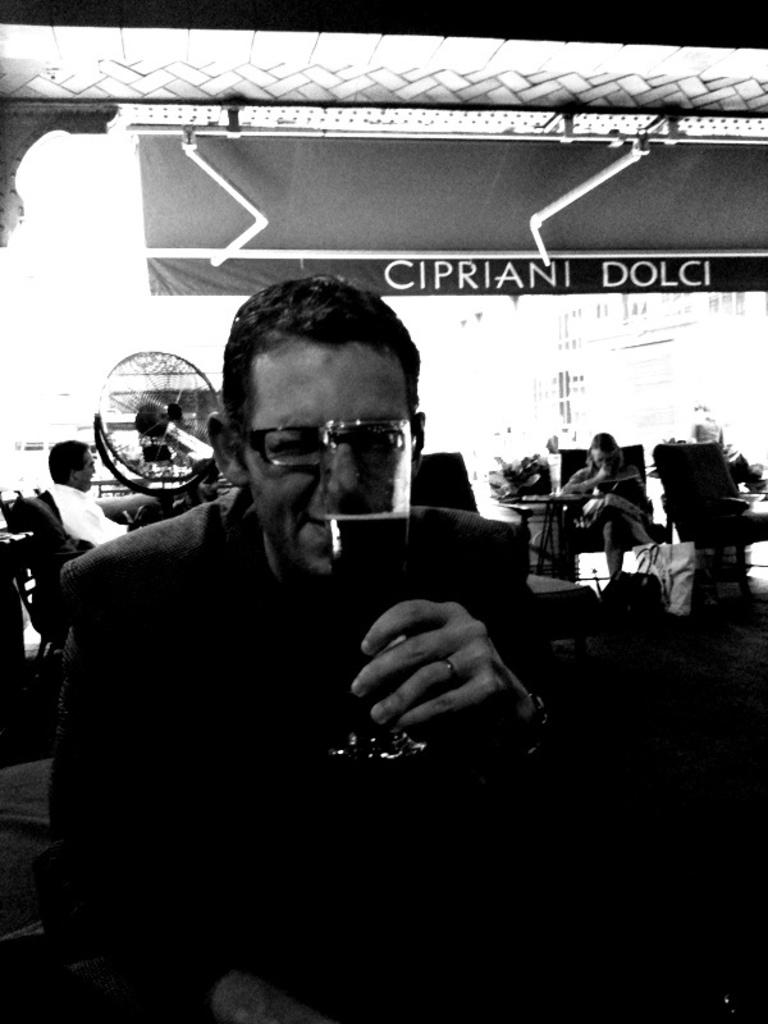What is the man in the image doing? The man is sitting in the image. What is the man holding in his hand? The man is holding a glass tumbler in his hand. What can be seen on the wall or surface in the image? There is an advertisement visible in the image. What type of appliance is present in the image? There is a table fan in the image. How many persons are sitting in chairs in the image? There are persons sitting in chairs in the image. How far away is the pot from the man in the image? There is no pot present in the image, so it cannot be determined how far away it is from the man. 